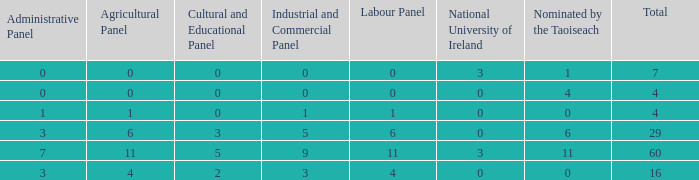What is the typical number of compositions None. 